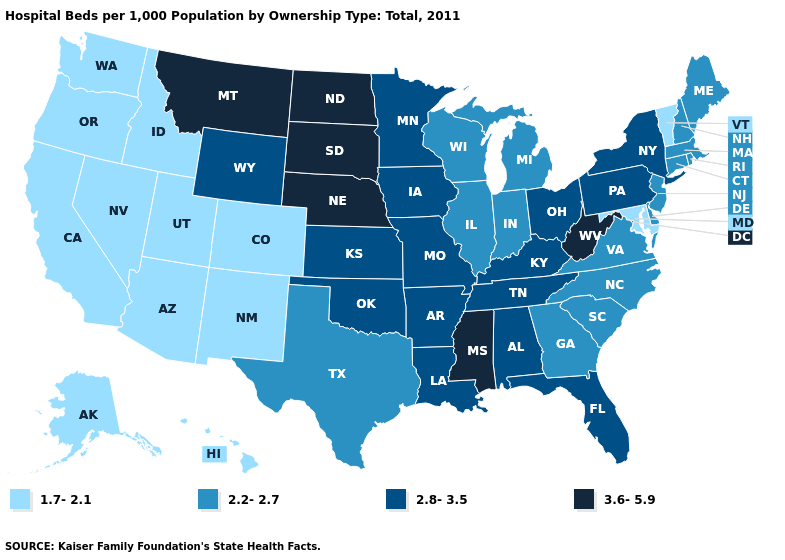What is the value of Iowa?
Keep it brief. 2.8-3.5. Among the states that border Mississippi , which have the lowest value?
Give a very brief answer. Alabama, Arkansas, Louisiana, Tennessee. Among the states that border Michigan , does Wisconsin have the highest value?
Quick response, please. No. Does Vermont have the lowest value in the Northeast?
Answer briefly. Yes. Does the first symbol in the legend represent the smallest category?
Be succinct. Yes. Which states hav the highest value in the South?
Concise answer only. Mississippi, West Virginia. What is the value of Maine?
Quick response, please. 2.2-2.7. Which states have the highest value in the USA?
Write a very short answer. Mississippi, Montana, Nebraska, North Dakota, South Dakota, West Virginia. Name the states that have a value in the range 1.7-2.1?
Concise answer only. Alaska, Arizona, California, Colorado, Hawaii, Idaho, Maryland, Nevada, New Mexico, Oregon, Utah, Vermont, Washington. What is the value of North Dakota?
Keep it brief. 3.6-5.9. Does West Virginia have the highest value in the USA?
Write a very short answer. Yes. Does Georgia have the highest value in the USA?
Write a very short answer. No. Which states have the lowest value in the USA?
Short answer required. Alaska, Arizona, California, Colorado, Hawaii, Idaho, Maryland, Nevada, New Mexico, Oregon, Utah, Vermont, Washington. Does South Dakota have a higher value than West Virginia?
Quick response, please. No. 